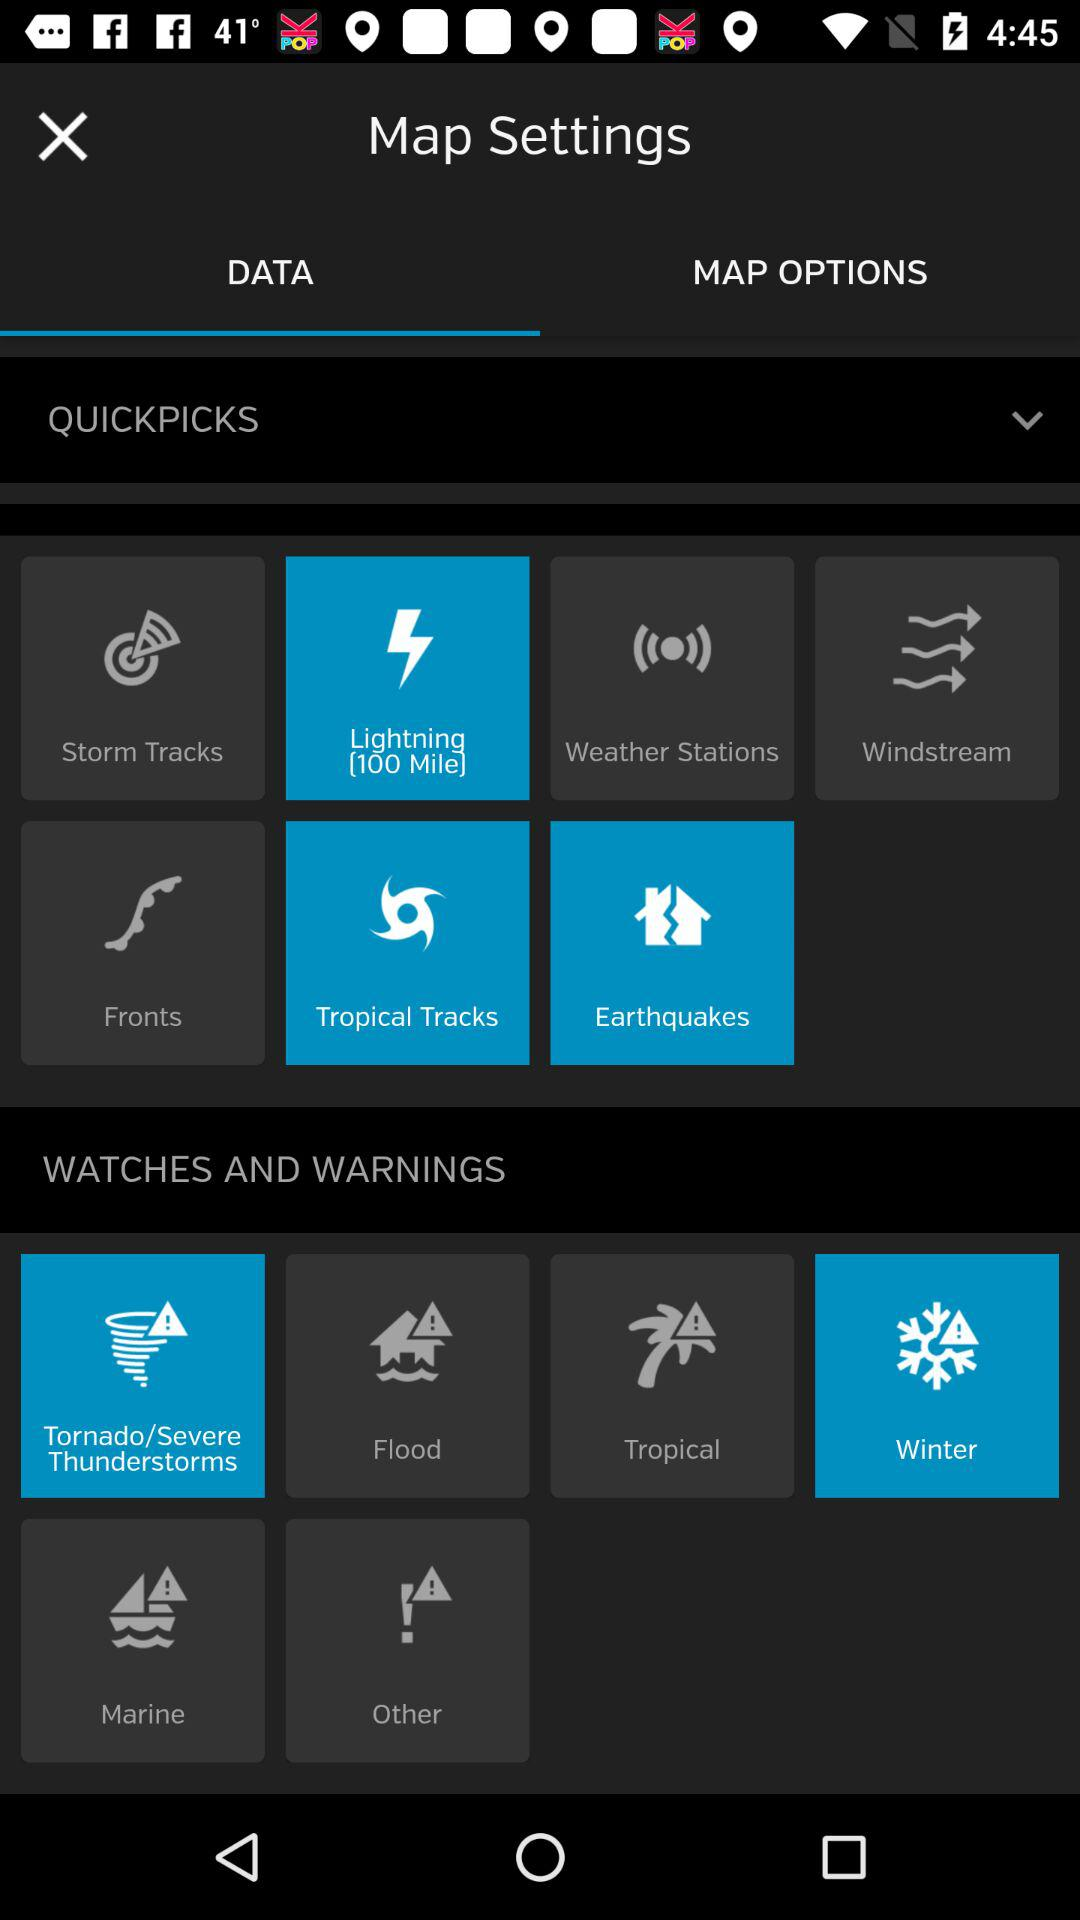Which tab am I on? You are on the "DATA" tab. 